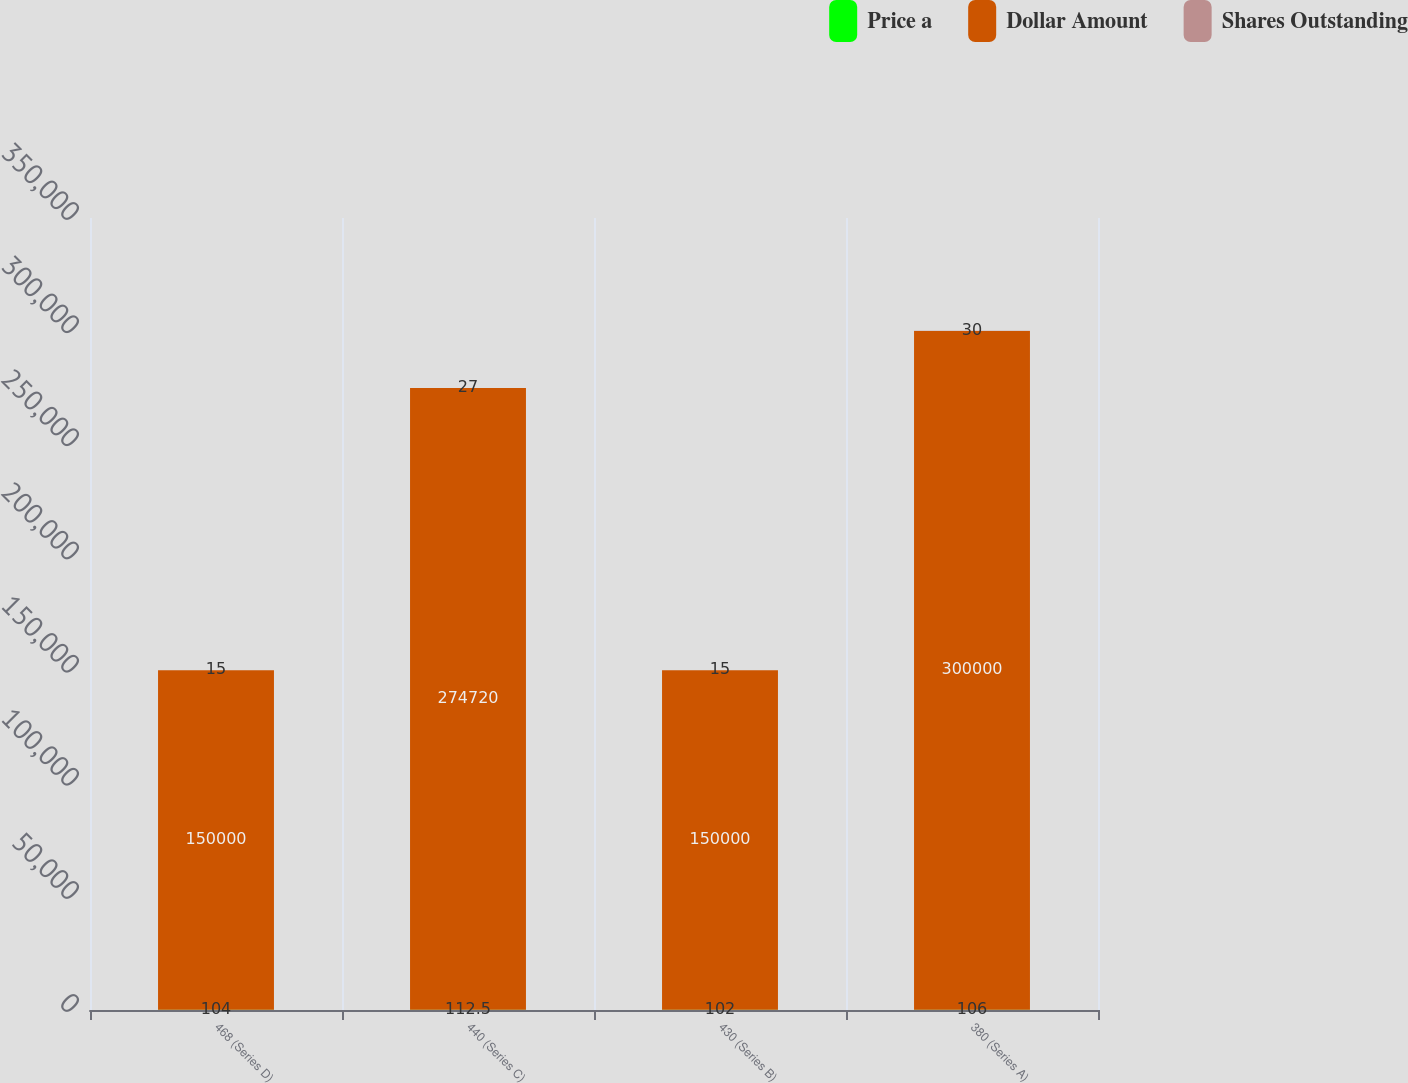Convert chart to OTSL. <chart><loc_0><loc_0><loc_500><loc_500><stacked_bar_chart><ecel><fcel>468 (Series D)<fcel>440 (Series C)<fcel>430 (Series B)<fcel>380 (Series A)<nl><fcel>Price a<fcel>104<fcel>112.5<fcel>102<fcel>106<nl><fcel>Dollar Amount<fcel>150000<fcel>274720<fcel>150000<fcel>300000<nl><fcel>Shares Outstanding<fcel>15<fcel>27<fcel>15<fcel>30<nl></chart> 